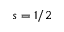Convert formula to latex. <formula><loc_0><loc_0><loc_500><loc_500>s = 1 / 2</formula> 